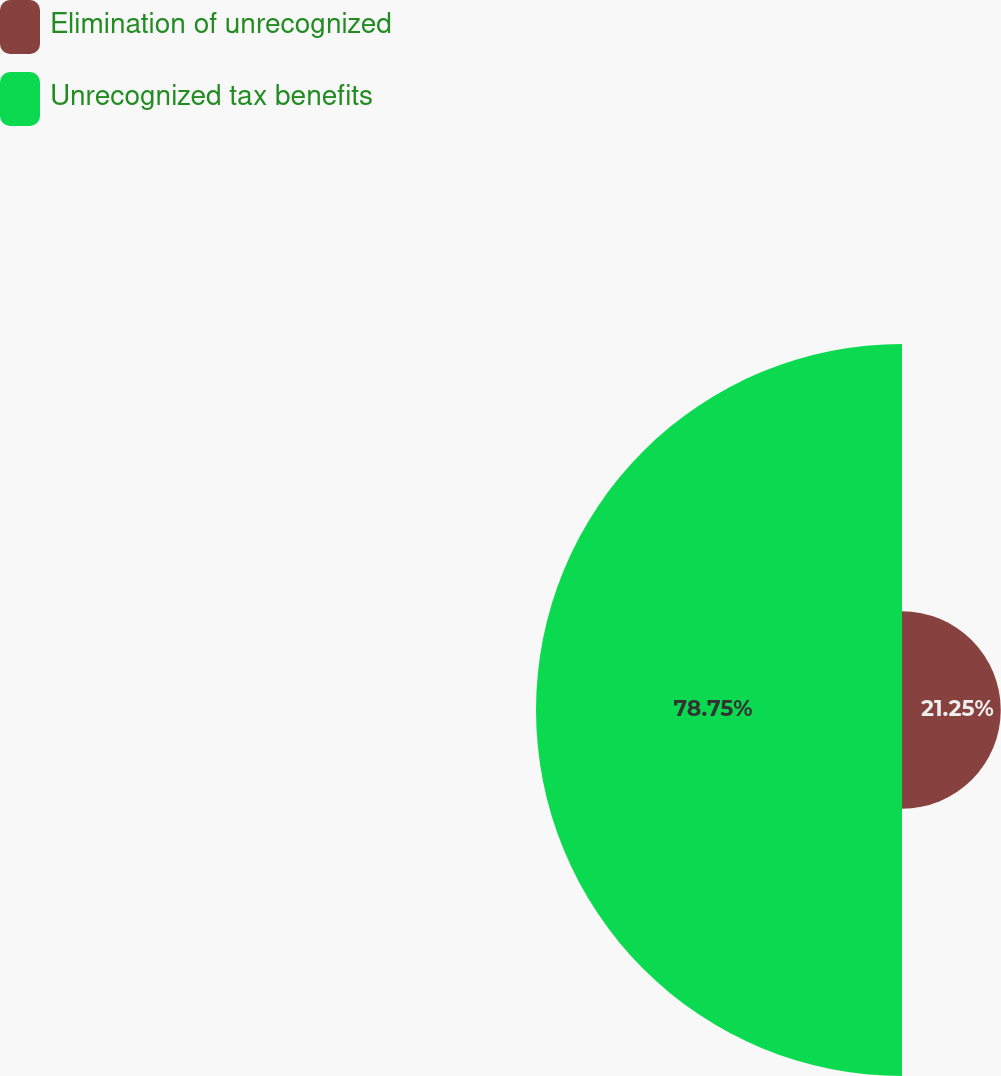Convert chart. <chart><loc_0><loc_0><loc_500><loc_500><pie_chart><fcel>Elimination of unrecognized<fcel>Unrecognized tax benefits<nl><fcel>21.25%<fcel>78.75%<nl></chart> 